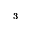Convert formula to latex. <formula><loc_0><loc_0><loc_500><loc_500>_ { 3 }</formula> 